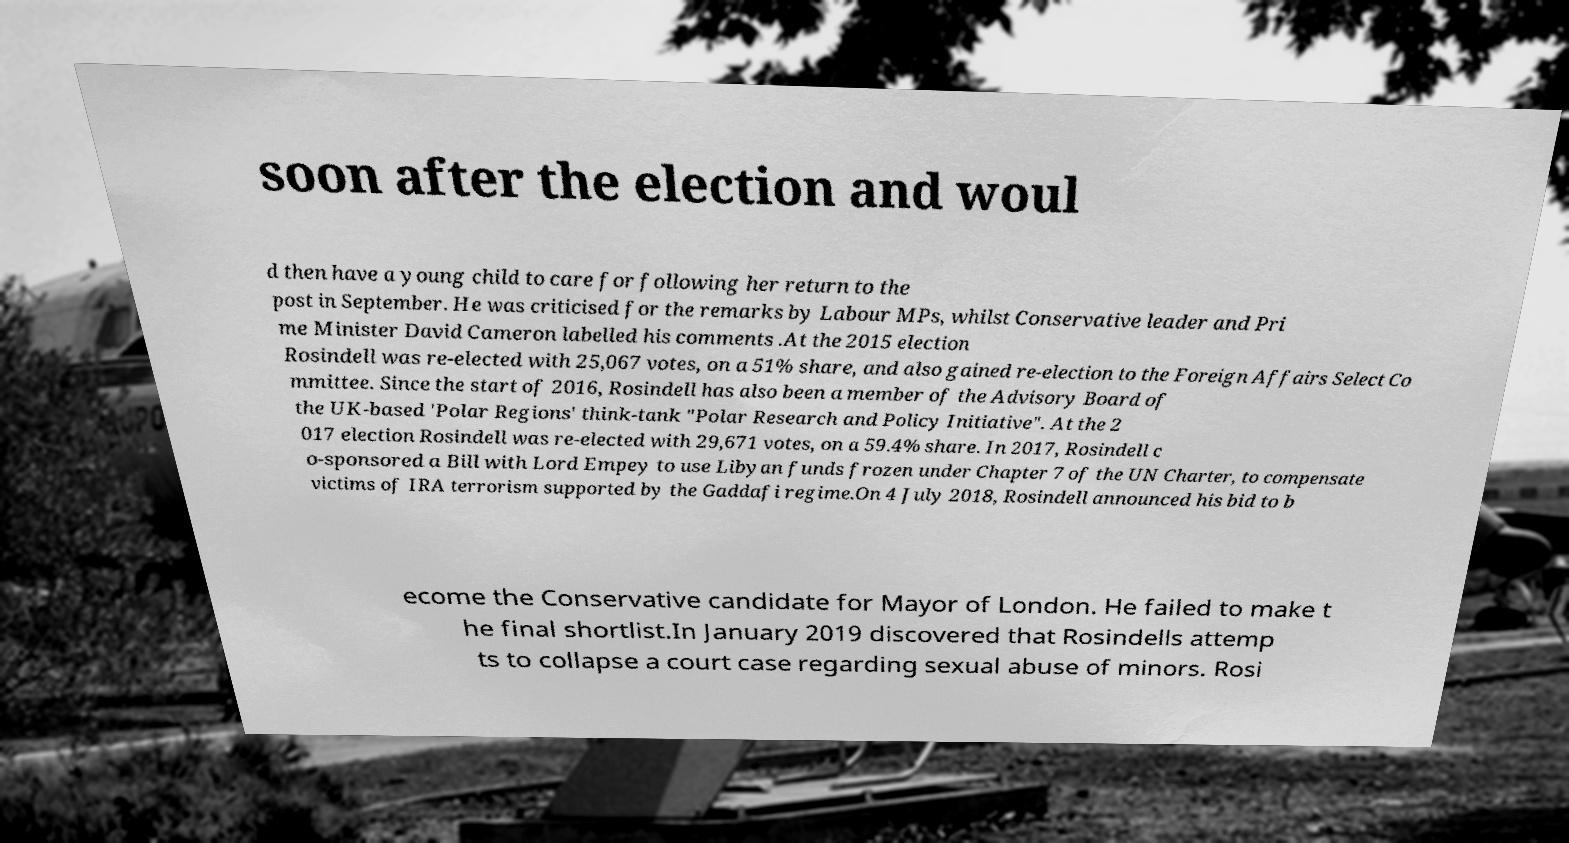Please read and relay the text visible in this image. What does it say? soon after the election and woul d then have a young child to care for following her return to the post in September. He was criticised for the remarks by Labour MPs, whilst Conservative leader and Pri me Minister David Cameron labelled his comments .At the 2015 election Rosindell was re-elected with 25,067 votes, on a 51% share, and also gained re-election to the Foreign Affairs Select Co mmittee. Since the start of 2016, Rosindell has also been a member of the Advisory Board of the UK-based 'Polar Regions' think-tank "Polar Research and Policy Initiative". At the 2 017 election Rosindell was re-elected with 29,671 votes, on a 59.4% share. In 2017, Rosindell c o-sponsored a Bill with Lord Empey to use Libyan funds frozen under Chapter 7 of the UN Charter, to compensate victims of IRA terrorism supported by the Gaddafi regime.On 4 July 2018, Rosindell announced his bid to b ecome the Conservative candidate for Mayor of London. He failed to make t he final shortlist.In January 2019 discovered that Rosindells attemp ts to collapse a court case regarding sexual abuse of minors. Rosi 